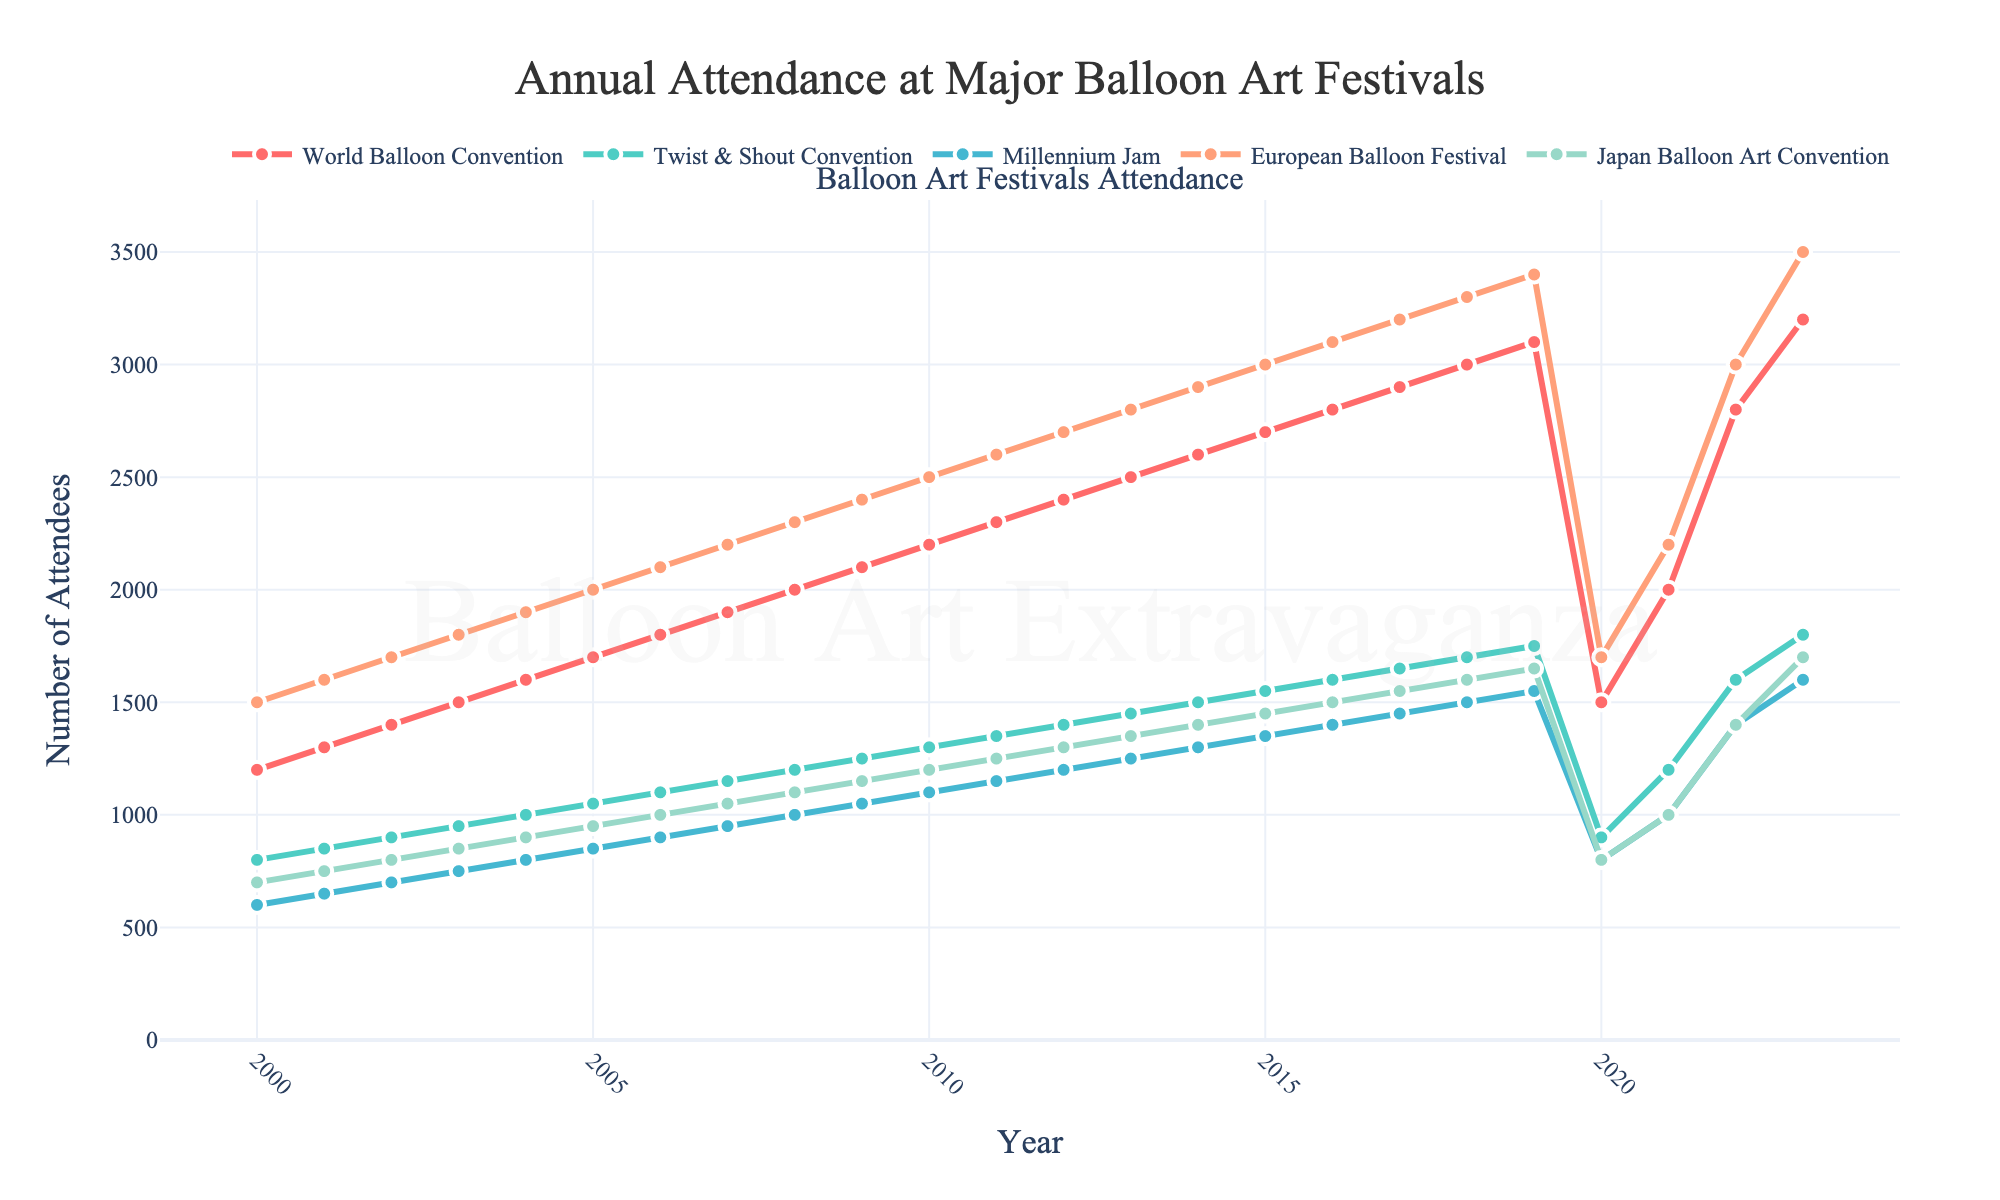What was the peak attendance for the European Balloon Festival before 2020? To find the peak attendance before 2020, we look at the data for the European Balloon Festival from 2000 to 2019. The peak attendance in this range is 3400 attendees in 2019.
Answer: 3400 How did the attendance for the World Balloon Convention change from 2000 to 2023? To determine the change in attendance, we look at the starting value in 2000 (1200 attendees) and the ending value in 2023 (3200 attendees). The change is calculated as 3200 - 1200.
Answer: Increase by 2000 Which festival had the largest drop in attendance in 2020 compared to 2019? We need to compare the drop in attendees from 2019 to 2020 for each festival. The differences are: 
- World Balloon Convention: 3100 - 1500 = 1600
- Twist & Shout Convention: 1750 - 900 = 850
- Millennium Jam: 1550 - 800 = 750
- European Balloon Festival: 3400 - 1700 = 1700
- Japan Balloon Art Convention: 1650 - 800 = 850
The largest drop occurred at the European Balloon Festival (1700 attendees).
Answer: European Balloon Festival What was the average attendance for the Twist & Shout Convention from 2000 to 2023? To find the average, sum the attendance figures for the Twist & Shout Convention between 2000 and 2023 and divide by the total number of years (24). The sum is 32150, so the average is 32150 / 24.
Answer: 1340.4 In 2023, which festival had the smallest number of attendees? To find this, we look at the attendance numbers for all festivals in 2023. The numbers are: 
- World Balloon Convention: 3200
- Twist & Shout Convention: 1800
- Millennium Jam: 1600
- European Balloon Festival: 3500
- Japan Balloon Art Convention: 1700
The smallest number is for the Millennium Jam (1600 attendees).
Answer: Millennium Jam Which color represents the European Balloon Festival on the plot? By examining the visual attributes of the plot, the festival lines are colored differently. The European Balloon Festival is represented by the orange line.
Answer: Orange How many festivals had more than 2000 attendees in 2019? We check the attendance in 2019 for each festival:
- World Balloon Convention: 3100
- Twist & Shout Convention: 1750
- Millennium Jam: 1550
- European Balloon Festival: 3400
- Japan Balloon Art Convention: 1650
The festivals with more than 2000 attendees are the World Balloon Convention and the European Balloon Festival.
Answer: 2 Between which years did the Japan Balloon Art Convention see the largest increase in attendance? We compare the annual increases in attendance for the Japan Balloon Art Convention from year to year and find the largest increase. The biggest increase is from 2022 (1400) to 2023 (1700), which is an increase of 300.
Answer: 2022 to 2023 